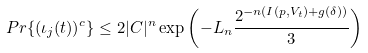Convert formula to latex. <formula><loc_0><loc_0><loc_500><loc_500>P r \{ ( \iota _ { j } ( t ) ) ^ { c } \} \leq 2 | C | ^ { n } \exp \left ( - L _ { n } \frac { 2 ^ { - n ( I ( p , V _ { t } ) + g ( \delta ) ) } } { 3 } \right )</formula> 